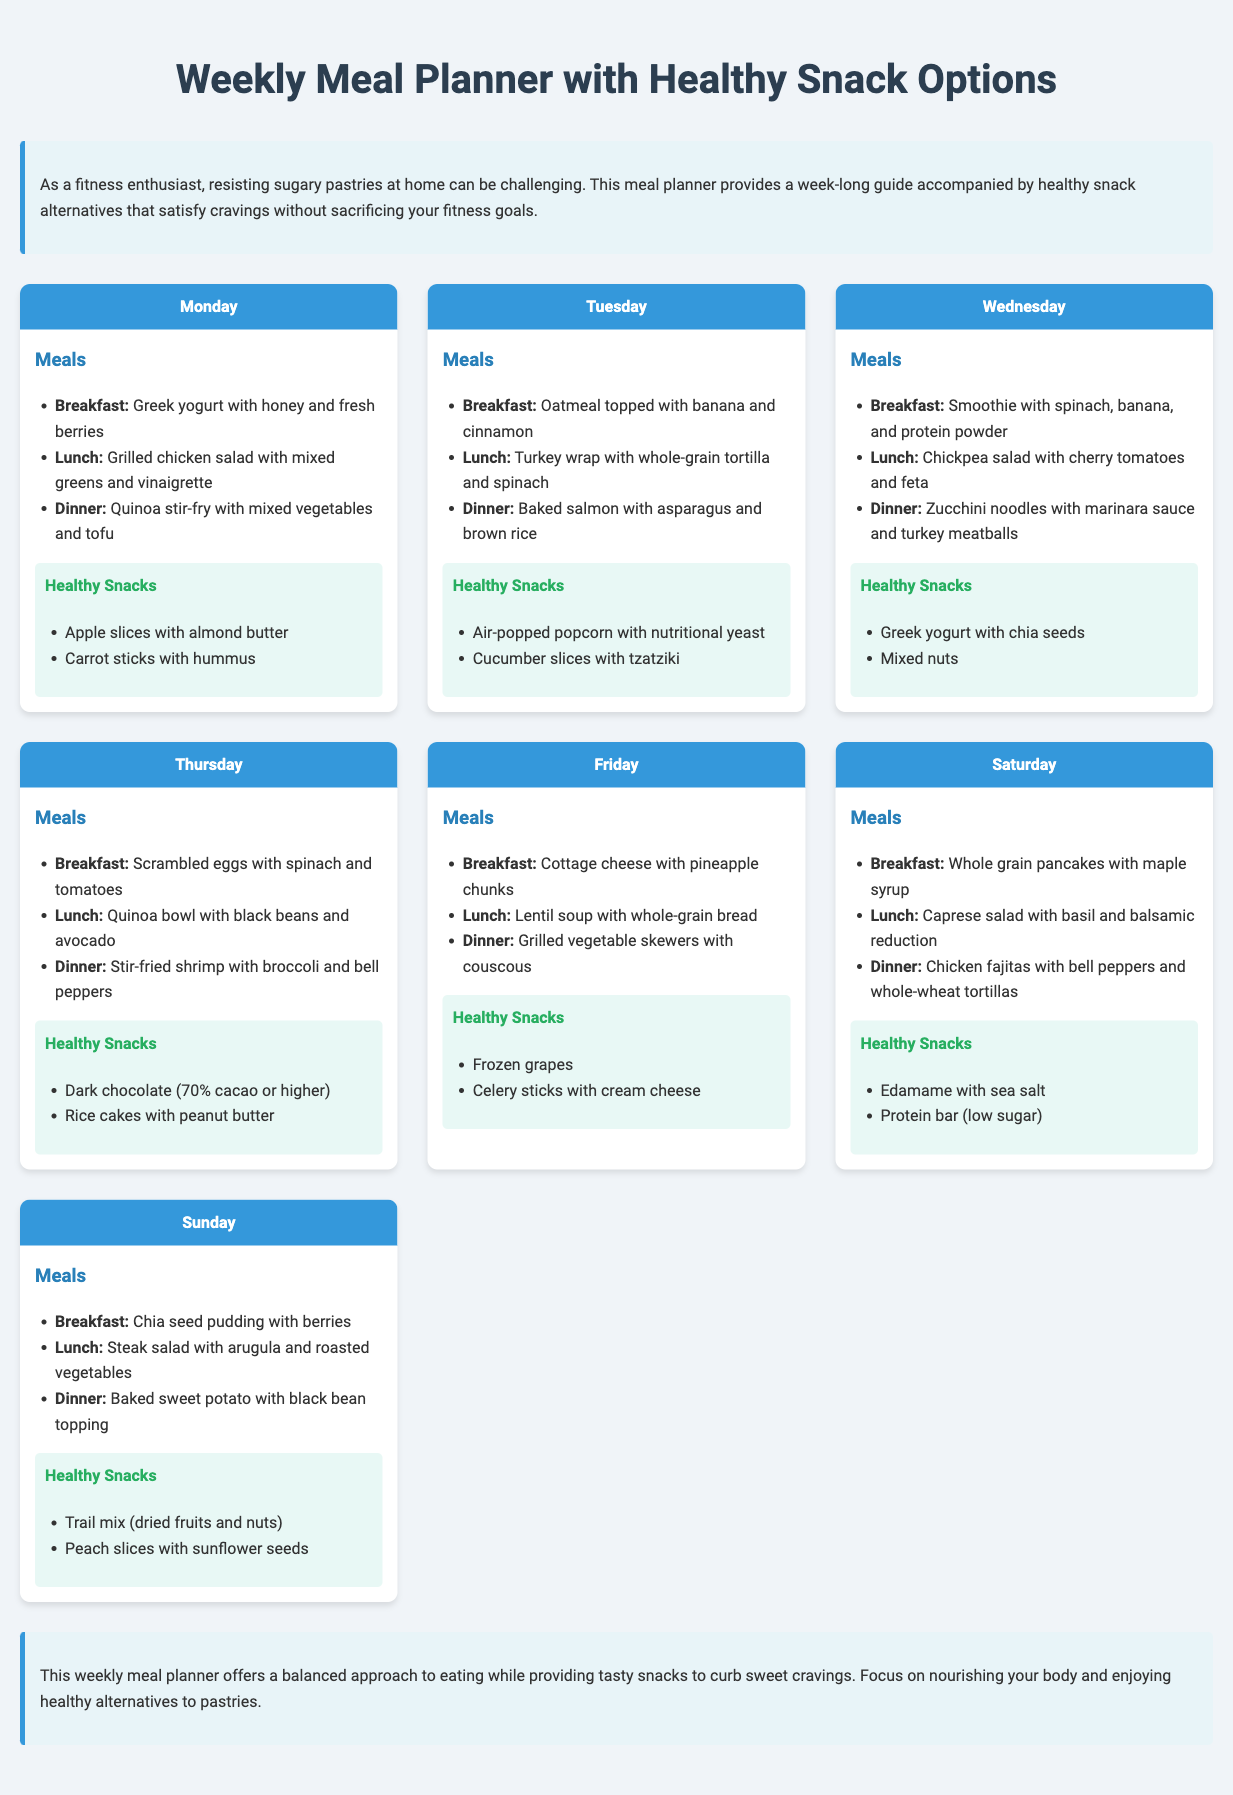what is the title of the document? The title is displayed prominently at the top of the document.
Answer: Weekly Meal Planner with Healthy Snack Options how many days are included in the meal planner? Each day of the week is covered in the meal planner, from Monday to Sunday.
Answer: 7 which snack is suggested for Monday? The healthy snacks section provides specific snack options for each day.
Answer: Apple slices with almond butter what type of meal is served for breakfast on Wednesday? The breakfast options are listed in the meal plan for each day.
Answer: Smoothie with spinach, banana, and protein powder which meal is suggested for dinner on Sunday? Dinner options are included for each day of the week in the meal planner.
Answer: Baked sweet potato with black bean topping what is one healthy snack option listed for Friday? The snacks are listed below each day's meals in the meal planner.
Answer: Frozen grapes which day has a meal featuring baked salmon? The lunch options include specific meals, which can be referenced to find the correct day.
Answer: Tuesday how are the snacks categorized in the document? Snacks are separately listed under a distinctive heading for each day.
Answer: Healthy Snacks 